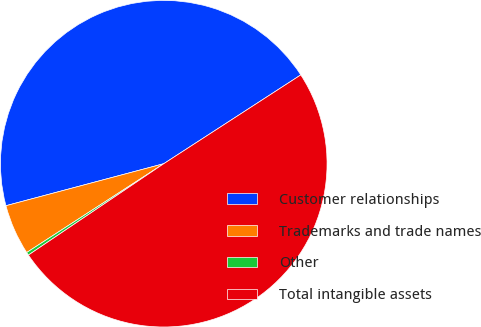Convert chart. <chart><loc_0><loc_0><loc_500><loc_500><pie_chart><fcel>Customer relationships<fcel>Trademarks and trade names<fcel>Other<fcel>Total intangible assets<nl><fcel>44.99%<fcel>5.01%<fcel>0.3%<fcel>49.7%<nl></chart> 